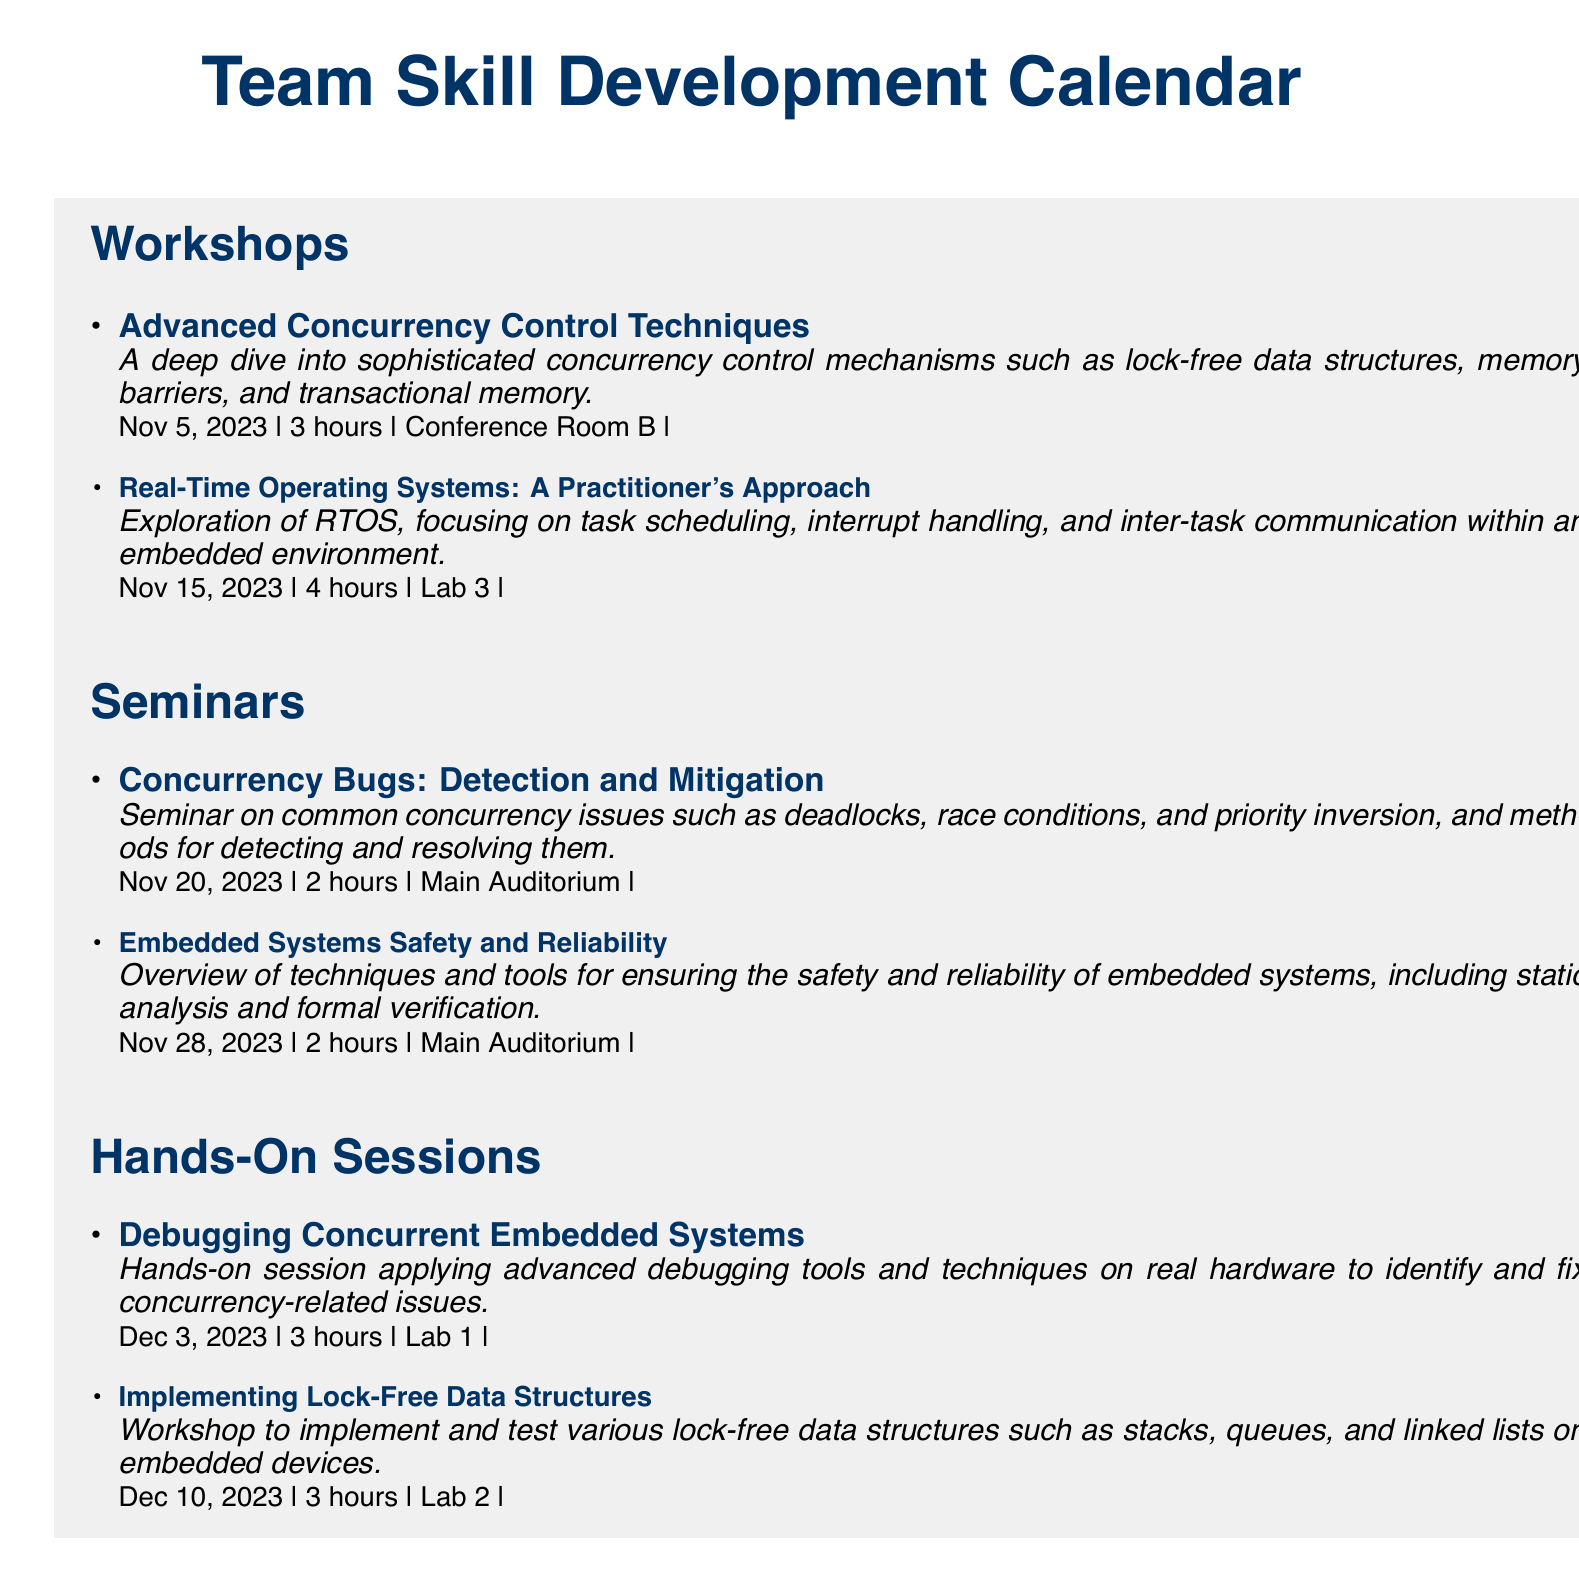What is the title of the first workshop? The title of the first workshop listed in the document is the first item under Workshops.
Answer: Advanced Concurrency Control Techniques When is the seminar on concurrency bugs scheduled? The date for the seminar on concurrency bugs can be found under the Seminars section.
Answer: Nov 20, 2023 How long is the hands-on session for debugging concurrent embedded systems? The duration of the hands-on session can be determined from the details provided in the Hands-On Sessions section.
Answer: 3 hours What room will the workshop on real-time operating systems take place in? The room information for the workshop is specified in the event details for that workshop.
Answer: Lab 3 How many hours is the seminar on embedded systems safety and reliability? The duration of the seminar is explicitly mentioned in the Seminars section of the document.
Answer: 2 hours What type of training event is scheduled for December 10, 2023? The type of training event can be identified based on the date and title in the Hands-On Sessions section.
Answer: Hands-On Session Which topic is covered in the seminar scheduled for November 28, 2023? The topic can be found by reviewing the event details in the Seminars section.
Answer: Embedded Systems Safety and Reliability How many hours are dedicated to the Advanced Concurrency Control Techniques workshop? The duration of the workshop is included in the event details.
Answer: 3 hours What is the primary focus of the hands-on session on December 3, 2023? The focus can be inferred from the event description given in the document.
Answer: Debugging Concurrent Embedded Systems 